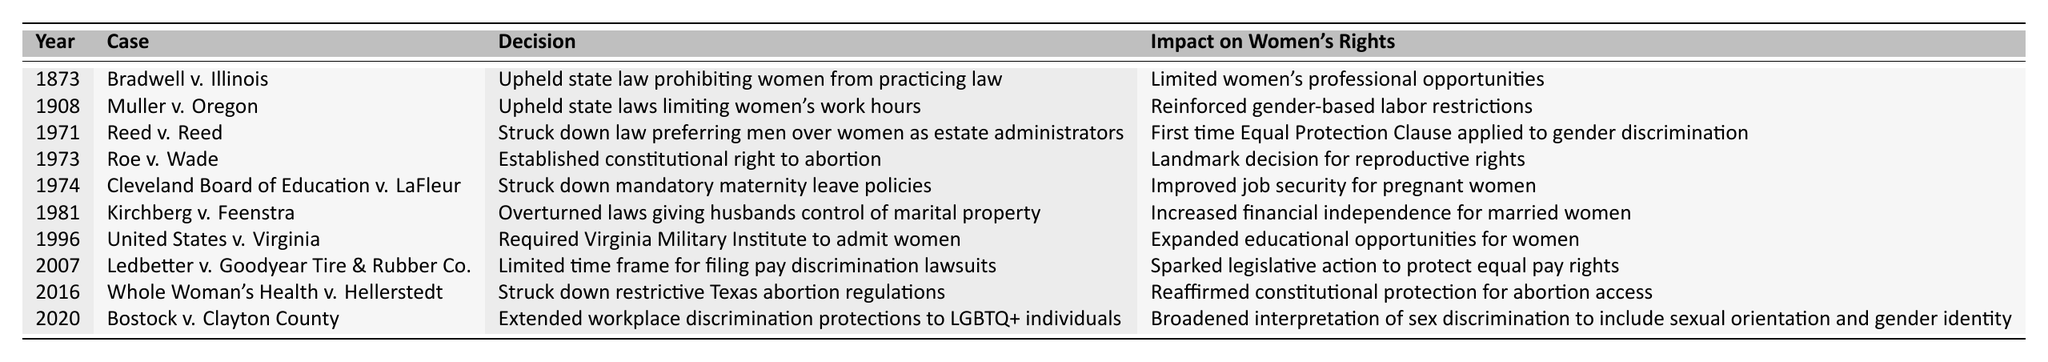What was the decision made in Roe v. Wade? The table lists that Roe v. Wade established the constitutional right to abortion.
Answer: Established constitutional right to abortion What year did the United States v. Virginia decision occur? Looking at the table, United States v. Virginia occurred in 1996.
Answer: 1996 Which case first applied the Equal Protection Clause to gender discrimination? The table indicates that Reed v. Reed is the case where the Equal Protection Clause was first applied to gender discrimination, occurring in 1971.
Answer: Reed v. Reed Did any case in the table improve job security for pregnant women? The table shows that Cleveland Board of Education v. LaFleur struck down mandatory maternity leave policies, thereby improving job security for pregnant women.
Answer: Yes How many cases before 2000 focused on women's reproductive rights? The table highlights two cases specifically about reproductive rights: Roe v. Wade (1973) and Whole Woman's Health v. Hellerstedt (2016). Since we only count those before 2000, the answer is one case.
Answer: 1 What impact did Kirchberg v. Feenstra have on married women's financial independence? The table states that Kirchberg v. Feenstra overturned laws giving husbands control of marital property, increasing financial independence for married women.
Answer: Increased financial independence Which decision came last in the timeline? Looking at the table, Bostock v. Clayton County is the last decision, occurring in 2020.
Answer: Bostock v. Clayton County How many cases mentioned in the table related to educational opportunities for women? The table indicates one case regarding educational opportunity: United States v. Virginia, which required the admission of women to the Virginia Military Institute in 1996.
Answer: 1 Which decision had the most significant impact on reproductive rights? Referring to the impact column, Roe v. Wade is noted as a landmark decision for reproductive rights since it established the constitutional right to abortion.
Answer: Roe v. Wade Was there any case that limited women's work hours, and what was it? The table mentions Muller v. Oregon, which upheld state laws limiting women's work hours, thus indicating that there was a case that limited those hours.
Answer: Yes, Muller v. Oregon What is the total number of Supreme Court decisions affecting women's rights listed in the table? The table contains a total of ten listed decisions regarding women's rights, as counted from the data provided.
Answer: 10 